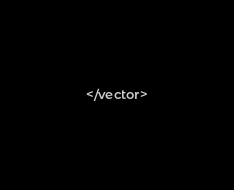<code> <loc_0><loc_0><loc_500><loc_500><_XML_></vector>
</code> 